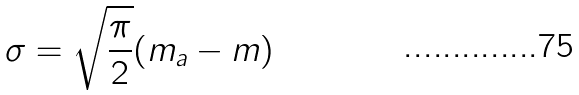Convert formula to latex. <formula><loc_0><loc_0><loc_500><loc_500>\sigma = \sqrt { \frac { \pi } { 2 } } ( m _ { a } - m )</formula> 